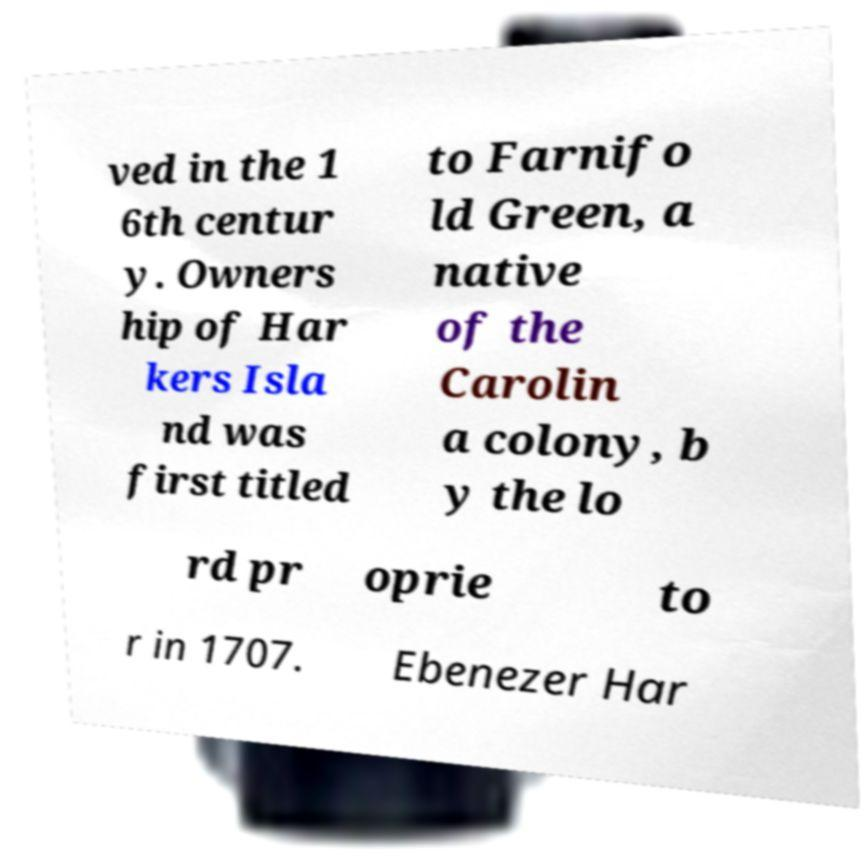I need the written content from this picture converted into text. Can you do that? ved in the 1 6th centur y. Owners hip of Har kers Isla nd was first titled to Farnifo ld Green, a native of the Carolin a colony, b y the lo rd pr oprie to r in 1707. Ebenezer Har 